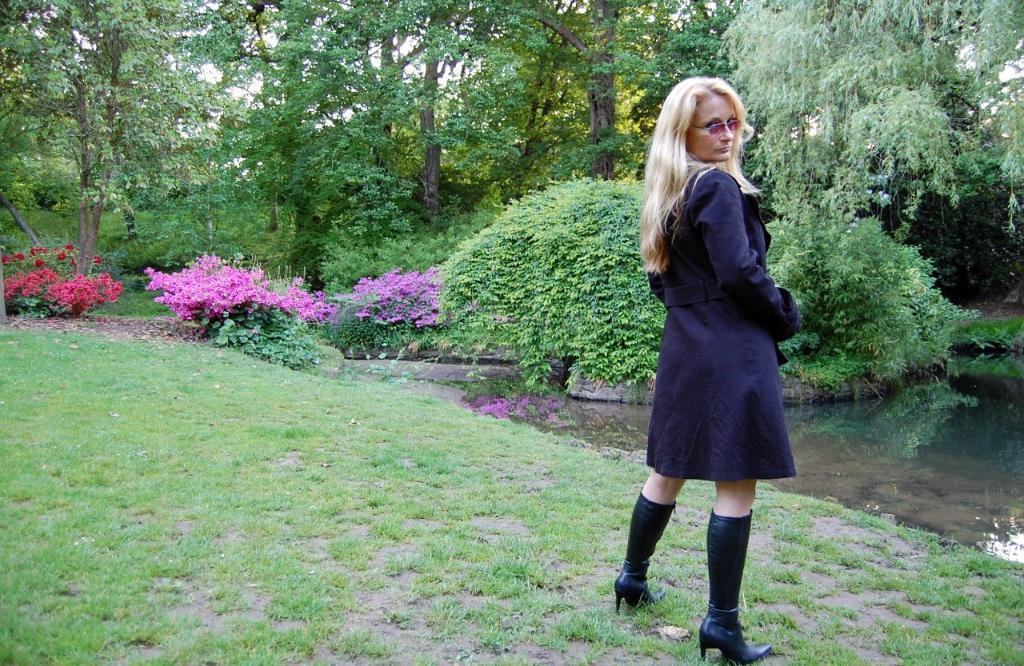In one or two sentences, can you explain what this image depicts? In this picture there is a woman who is standing on the grass. In the background I can see many trees, plants and grass. On the left I can see red and pink color flowers on the plant. In the background I can see the sky. On the right I can see the water. 